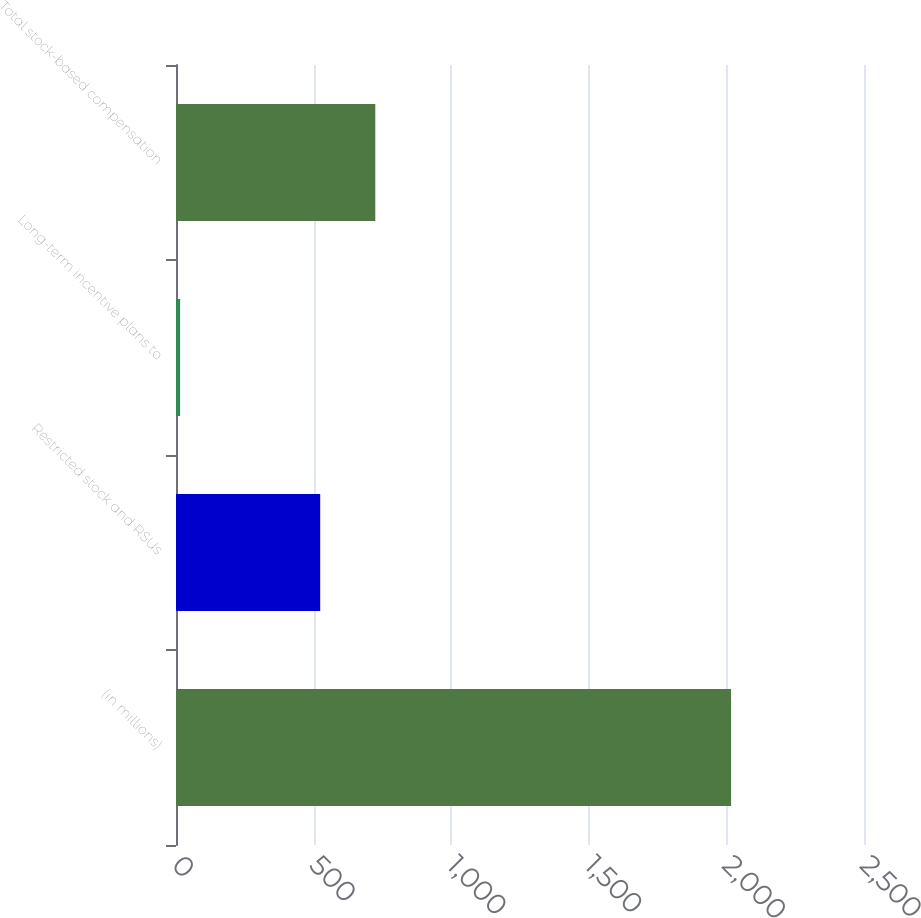Convert chart to OTSL. <chart><loc_0><loc_0><loc_500><loc_500><bar_chart><fcel>(in millions)<fcel>Restricted stock and RSUs<fcel>Long-term incentive plans to<fcel>Total stock-based compensation<nl><fcel>2017<fcel>524<fcel>15<fcel>724.2<nl></chart> 